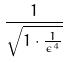<formula> <loc_0><loc_0><loc_500><loc_500>\frac { 1 } { \sqrt { 1 \cdot \frac { 1 } { \epsilon ^ { 4 } } } }</formula> 